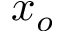Convert formula to latex. <formula><loc_0><loc_0><loc_500><loc_500>x _ { o }</formula> 